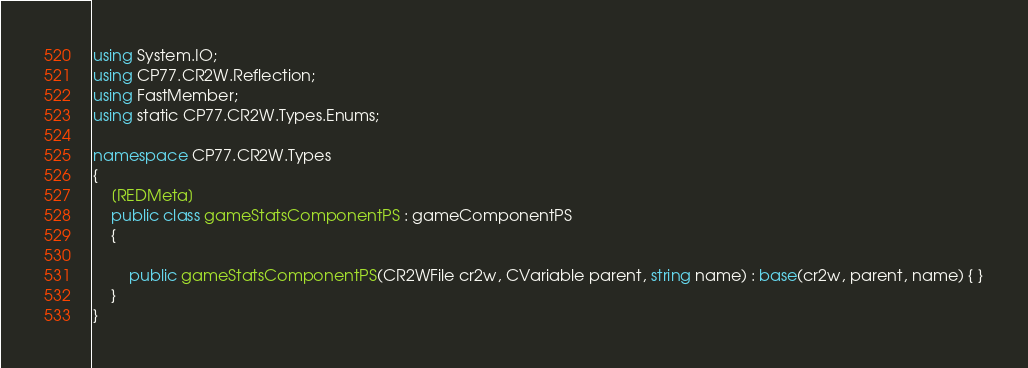Convert code to text. <code><loc_0><loc_0><loc_500><loc_500><_C#_>using System.IO;
using CP77.CR2W.Reflection;
using FastMember;
using static CP77.CR2W.Types.Enums;

namespace CP77.CR2W.Types
{
	[REDMeta]
	public class gameStatsComponentPS : gameComponentPS
	{

		public gameStatsComponentPS(CR2WFile cr2w, CVariable parent, string name) : base(cr2w, parent, name) { }
	}
}
</code> 